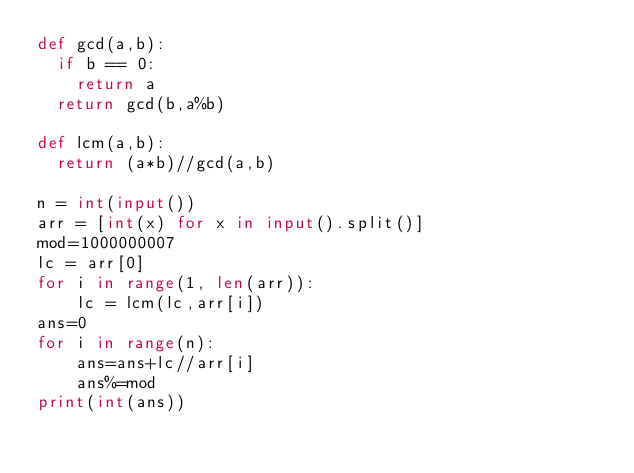Convert code to text. <code><loc_0><loc_0><loc_500><loc_500><_Python_>def gcd(a,b):
  if b == 0:
    return a
  return gcd(b,a%b)

def lcm(a,b):
  return (a*b)//gcd(a,b)
 
n = int(input())
arr = [int(x) for x in input().split()] 
mod=1000000007
lc = arr[0]
for i in range(1, len(arr)): 
  	lc = lcm(lc,arr[i])
ans=0
for i in range(n):
    ans=ans+lc//arr[i]
    ans%=mod
print(int(ans))</code> 